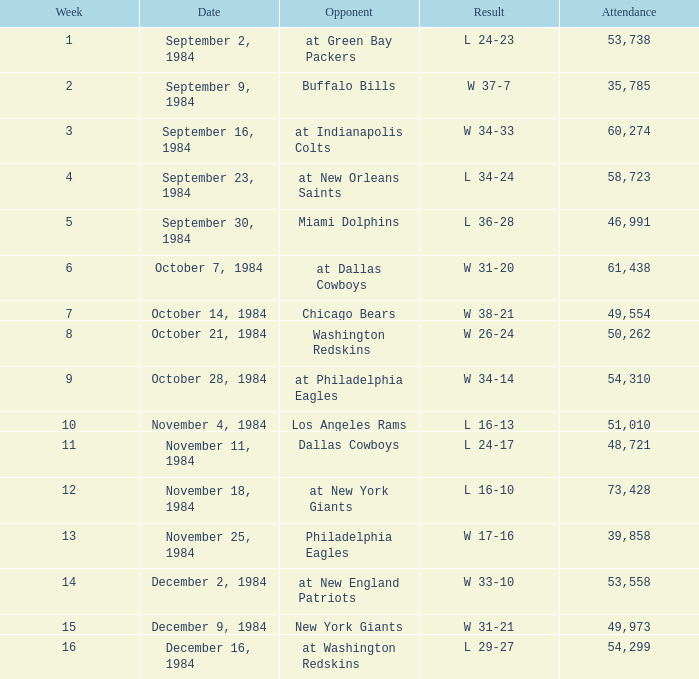What is the total attendance when the outcome was 16-13? 51010.0. 